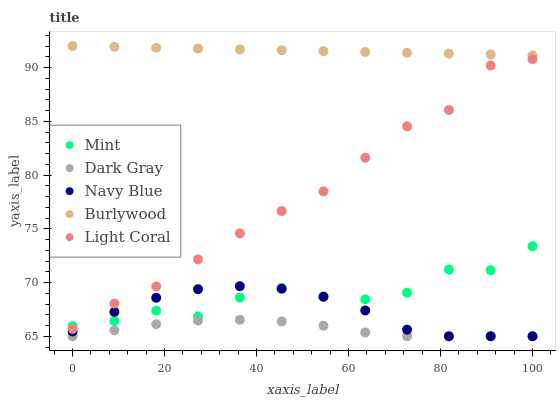Does Dark Gray have the minimum area under the curve?
Answer yes or no. Yes. Does Burlywood have the maximum area under the curve?
Answer yes or no. Yes. Does Navy Blue have the minimum area under the curve?
Answer yes or no. No. Does Navy Blue have the maximum area under the curve?
Answer yes or no. No. Is Burlywood the smoothest?
Answer yes or no. Yes. Is Mint the roughest?
Answer yes or no. Yes. Is Navy Blue the smoothest?
Answer yes or no. No. Is Navy Blue the roughest?
Answer yes or no. No. Does Dark Gray have the lowest value?
Answer yes or no. Yes. Does Light Coral have the lowest value?
Answer yes or no. No. Does Burlywood have the highest value?
Answer yes or no. Yes. Does Navy Blue have the highest value?
Answer yes or no. No. Is Navy Blue less than Light Coral?
Answer yes or no. Yes. Is Burlywood greater than Light Coral?
Answer yes or no. Yes. Does Mint intersect Navy Blue?
Answer yes or no. Yes. Is Mint less than Navy Blue?
Answer yes or no. No. Is Mint greater than Navy Blue?
Answer yes or no. No. Does Navy Blue intersect Light Coral?
Answer yes or no. No. 